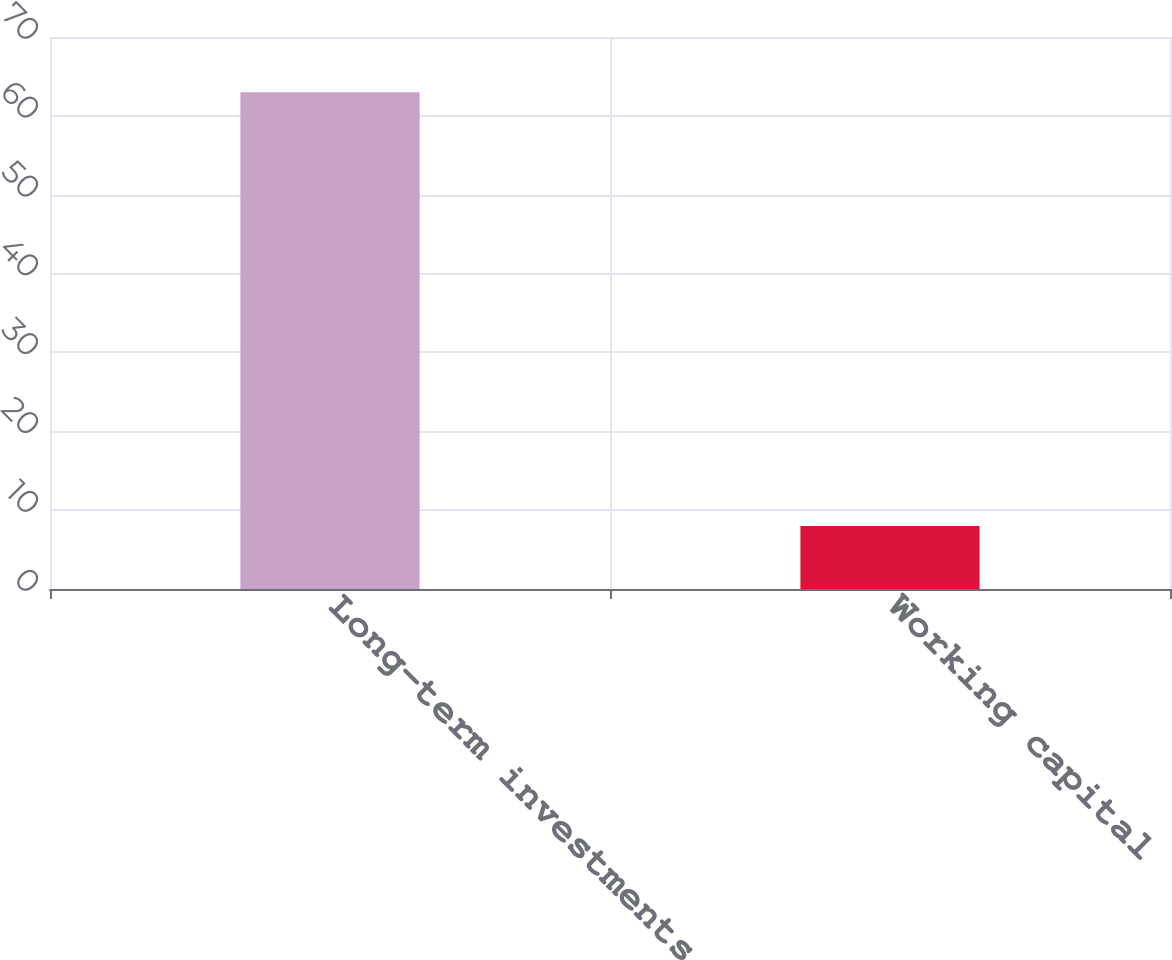Convert chart to OTSL. <chart><loc_0><loc_0><loc_500><loc_500><bar_chart><fcel>Long-term investments<fcel>Working capital<nl><fcel>63<fcel>8<nl></chart> 